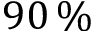Convert formula to latex. <formula><loc_0><loc_0><loc_500><loc_500>9 0 \, \%</formula> 